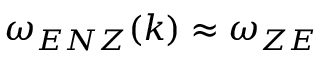Convert formula to latex. <formula><loc_0><loc_0><loc_500><loc_500>\omega _ { E N Z } ( k ) \approx \omega _ { Z E }</formula> 